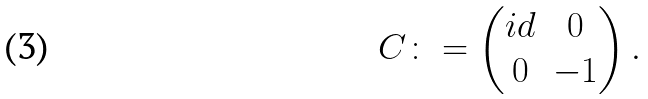<formula> <loc_0><loc_0><loc_500><loc_500>C \colon = \begin{pmatrix} i d & 0 \\ 0 & - 1 \end{pmatrix} .</formula> 